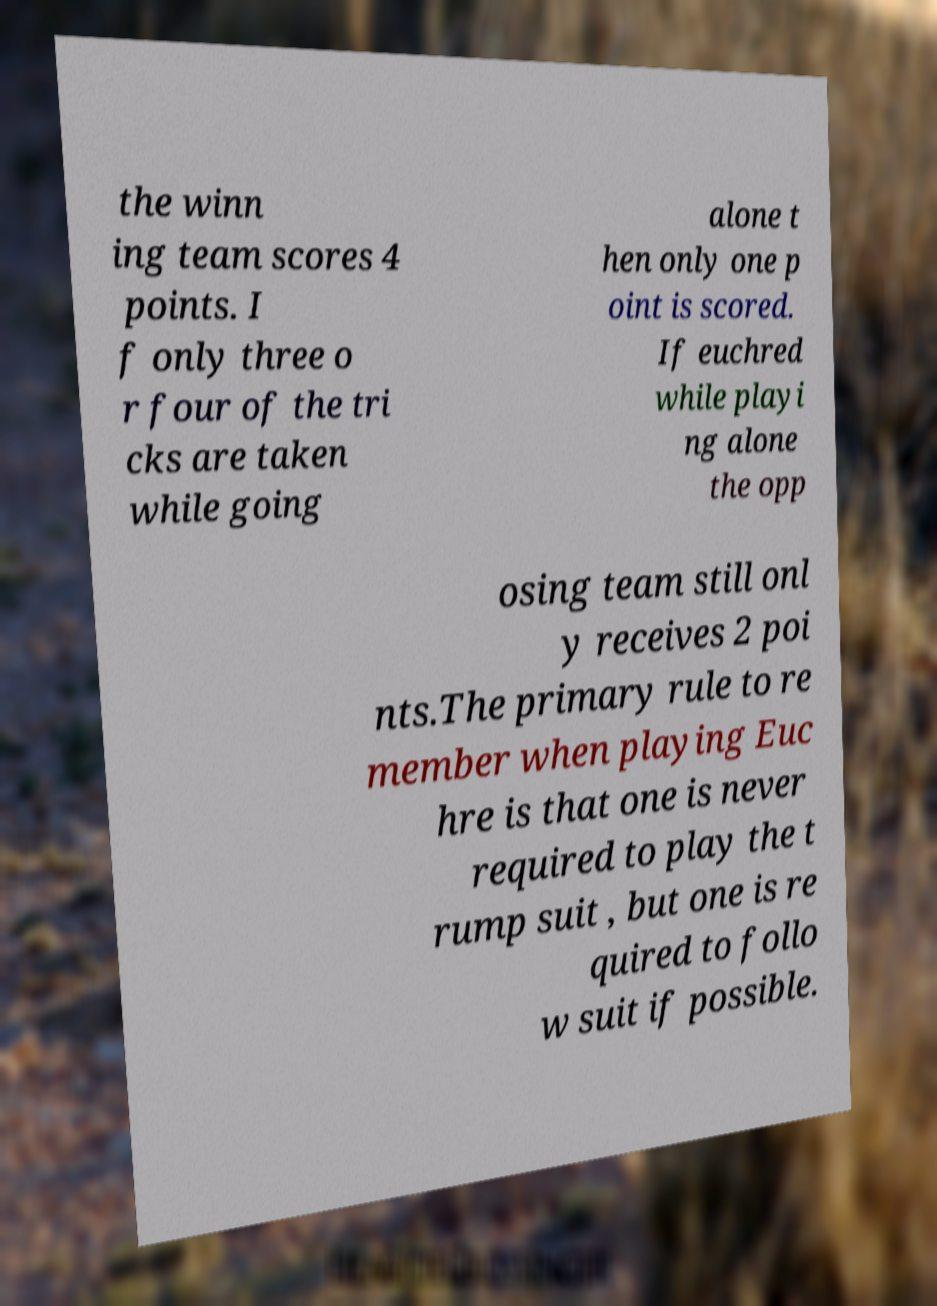Could you assist in decoding the text presented in this image and type it out clearly? the winn ing team scores 4 points. I f only three o r four of the tri cks are taken while going alone t hen only one p oint is scored. If euchred while playi ng alone the opp osing team still onl y receives 2 poi nts.The primary rule to re member when playing Euc hre is that one is never required to play the t rump suit , but one is re quired to follo w suit if possible. 